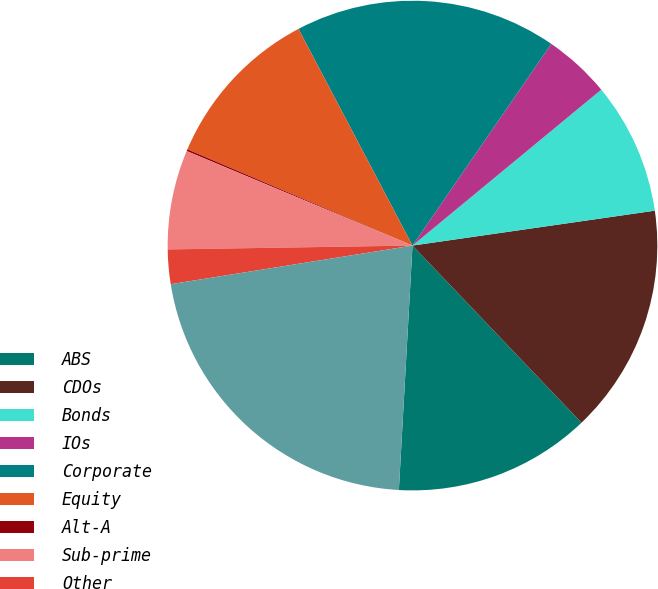Convert chart. <chart><loc_0><loc_0><loc_500><loc_500><pie_chart><fcel>ABS<fcel>CDOs<fcel>Bonds<fcel>IOs<fcel>Corporate<fcel>Equity<fcel>Alt-A<fcel>Sub-prime<fcel>Other<fcel>Total<nl><fcel>13.01%<fcel>15.15%<fcel>8.71%<fcel>4.42%<fcel>17.3%<fcel>10.86%<fcel>0.12%<fcel>6.56%<fcel>2.27%<fcel>21.59%<nl></chart> 